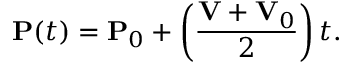<formula> <loc_0><loc_0><loc_500><loc_500>P ( t ) = P _ { 0 } + \left ( { \frac { V + V _ { 0 } } { 2 } } \right ) t .</formula> 